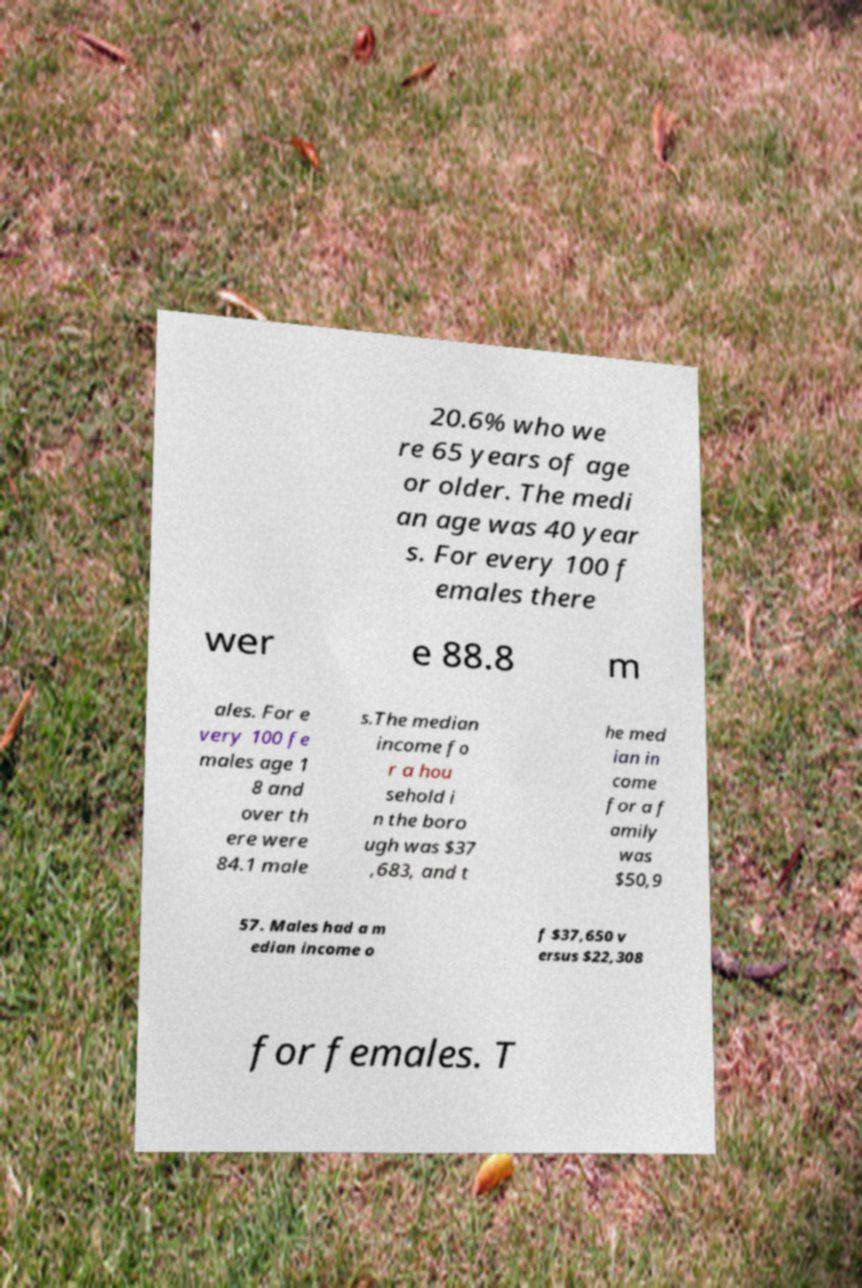I need the written content from this picture converted into text. Can you do that? 20.6% who we re 65 years of age or older. The medi an age was 40 year s. For every 100 f emales there wer e 88.8 m ales. For e very 100 fe males age 1 8 and over th ere were 84.1 male s.The median income fo r a hou sehold i n the boro ugh was $37 ,683, and t he med ian in come for a f amily was $50,9 57. Males had a m edian income o f $37,650 v ersus $22,308 for females. T 